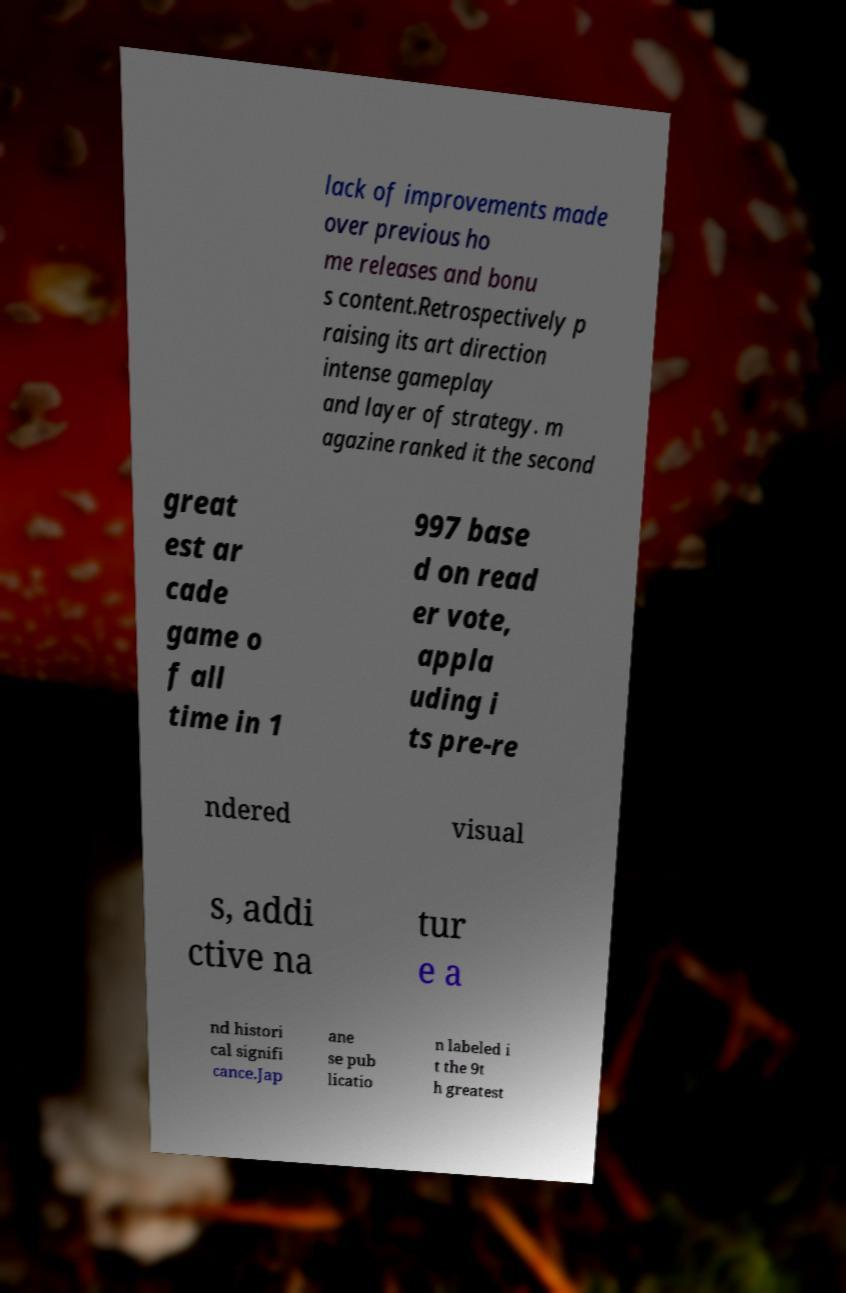Please identify and transcribe the text found in this image. lack of improvements made over previous ho me releases and bonu s content.Retrospectively p raising its art direction intense gameplay and layer of strategy. m agazine ranked it the second great est ar cade game o f all time in 1 997 base d on read er vote, appla uding i ts pre-re ndered visual s, addi ctive na tur e a nd histori cal signifi cance.Jap ane se pub licatio n labeled i t the 9t h greatest 